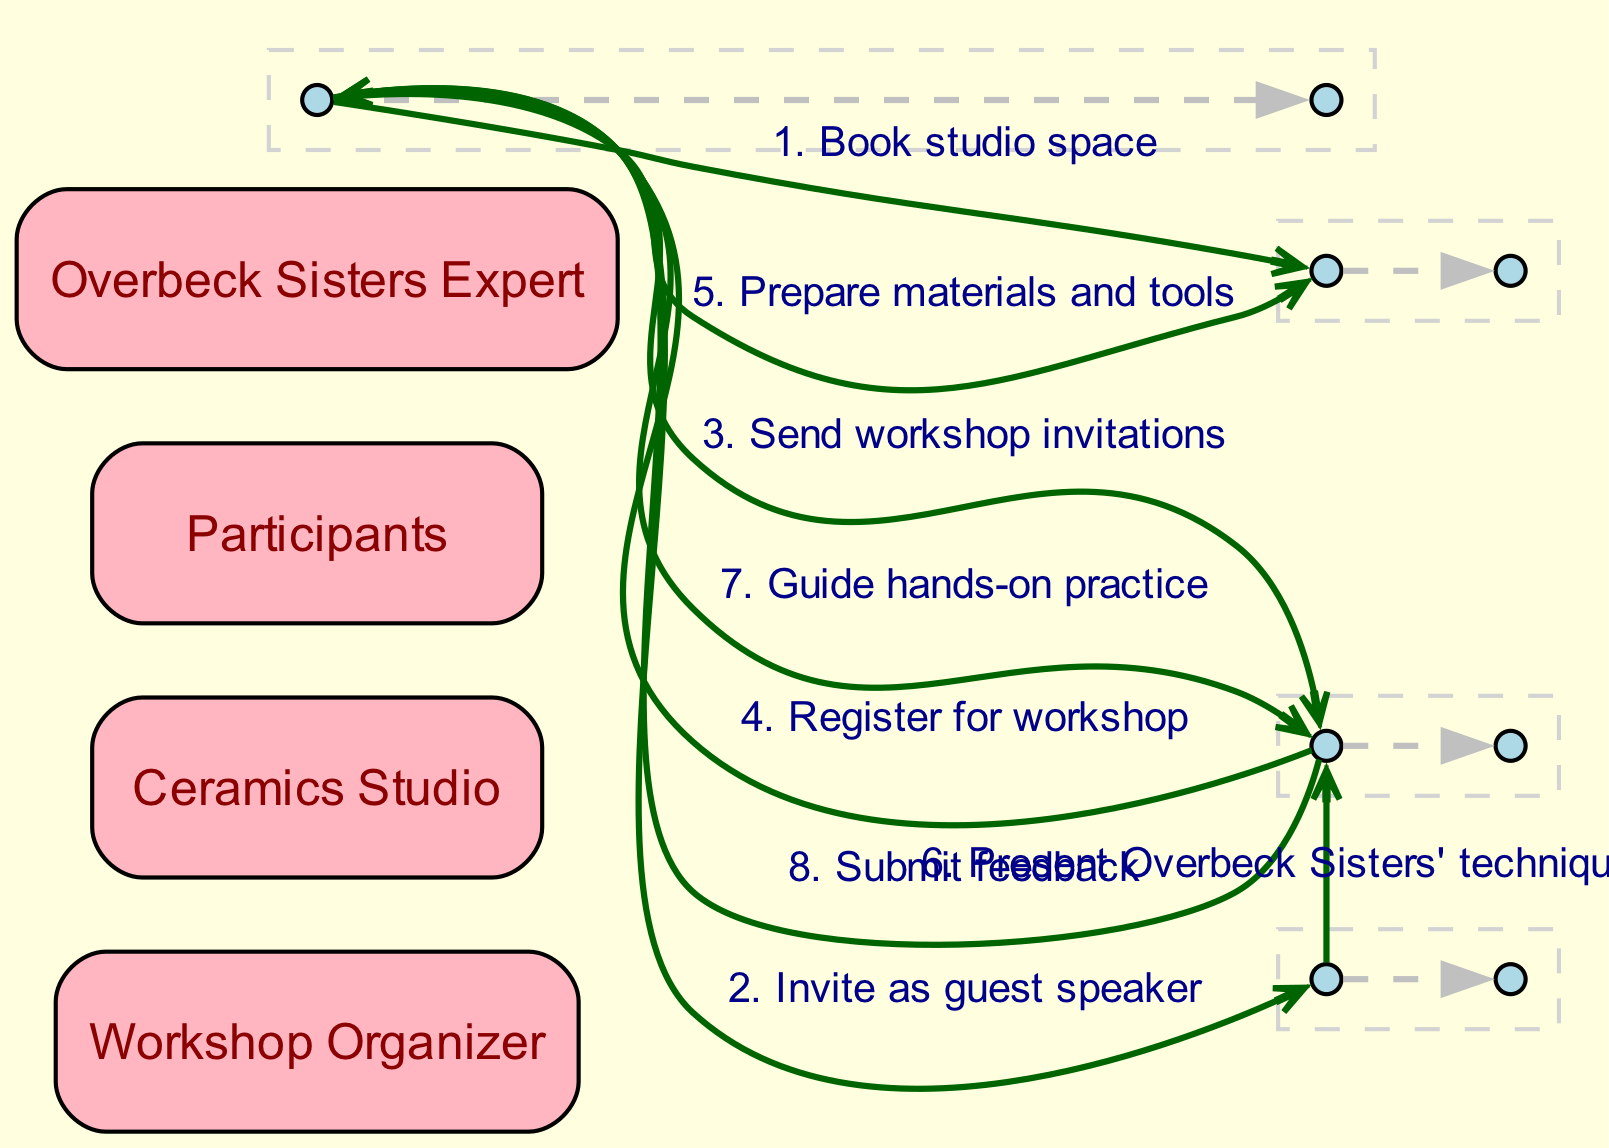What is the first action that the Workshop Organizer takes? The first action performed by the Workshop Organizer, as seen in the sequence, is to "Book studio space". This is the initial step before proceeding with any other actions.
Answer: Book studio space How many main actors are involved in this workshop sequence? By counting the actors listed in the data, there are four main actors involved in this sequence: the Workshop Organizer, Ceramics Studio, Participants, and Overbeck Sisters Expert.
Answer: Four Which entity receives feedback from the Participants? The Participants submit feedback directly to the Workshop Organizer, as indicated in the last step of the sequence flow.
Answer: Workshop Organizer In which step does the Overbeck Sisters Expert interact with the Participants? The Overbeck Sisters Expert interacts with the Participants in the step where they "Present Overbeck Sisters' techniques". This follows after the studio space and materials have been prepared.
Answer: Present Overbeck Sisters' techniques What is the second action taken by the Workshop Organizer? The second action taken by the Workshop Organizer is to "Invite as guest speaker" directed towards the Overbeck Sisters Expert. This occurs right after booking the studio space.
Answer: Invite as guest speaker How many messages are exchanged between the Workshop Organizer and Participants? There are two messages exchanged between the Workshop Organizer and Participants: "Send workshop invitations" and "Guide hands-on practice". This indicates an ongoing communication between them.
Answer: Two What sequence number is assigned to the action of Participants registering for the workshop? The action of Participants registering for the workshop is assigned the sequence number three, as it is the third step in the flow of events.
Answer: Three Which action follows the preparation of materials and tools by the Workshop Organizer? The action that follows preparation of materials and tools by the Workshop Organizer is the presentation of Overbeck Sisters' techniques by the Overbeck Sisters Expert, marking the next step in the workflow.
Answer: Present Overbeck Sisters' techniques What is the last action that Participants take in the sequence? The last action taken by the Participants in the sequence is to "Submit feedback", which is the final step in the interaction flow described.
Answer: Submit feedback 